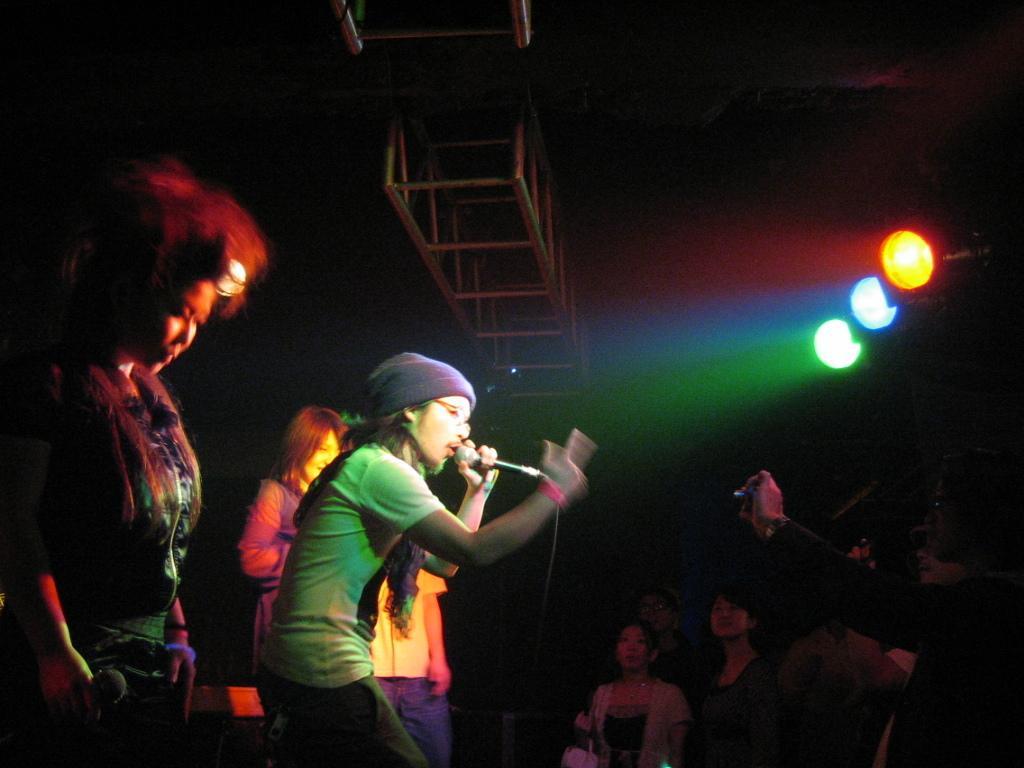Could you give a brief overview of what you see in this image? In the foreground, I can see a group of people on the floor and two persons are holding some objects in their hand. In the background, I can see lights, metal objects and a dark color. This image taken, maybe during night. 